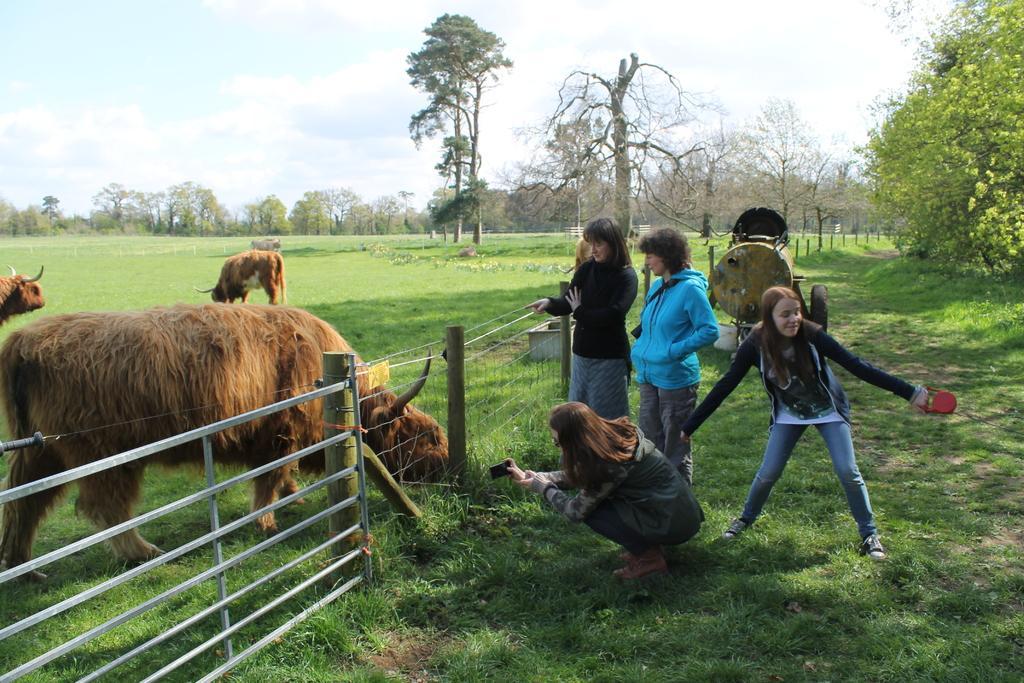In one or two sentences, can you explain what this image depicts? In this image I can see three people and one person is holding camera. In front I can see animals which are in brown color. I can see a fencing and machine. Back I can see trees. The sky is in white and blue color. 